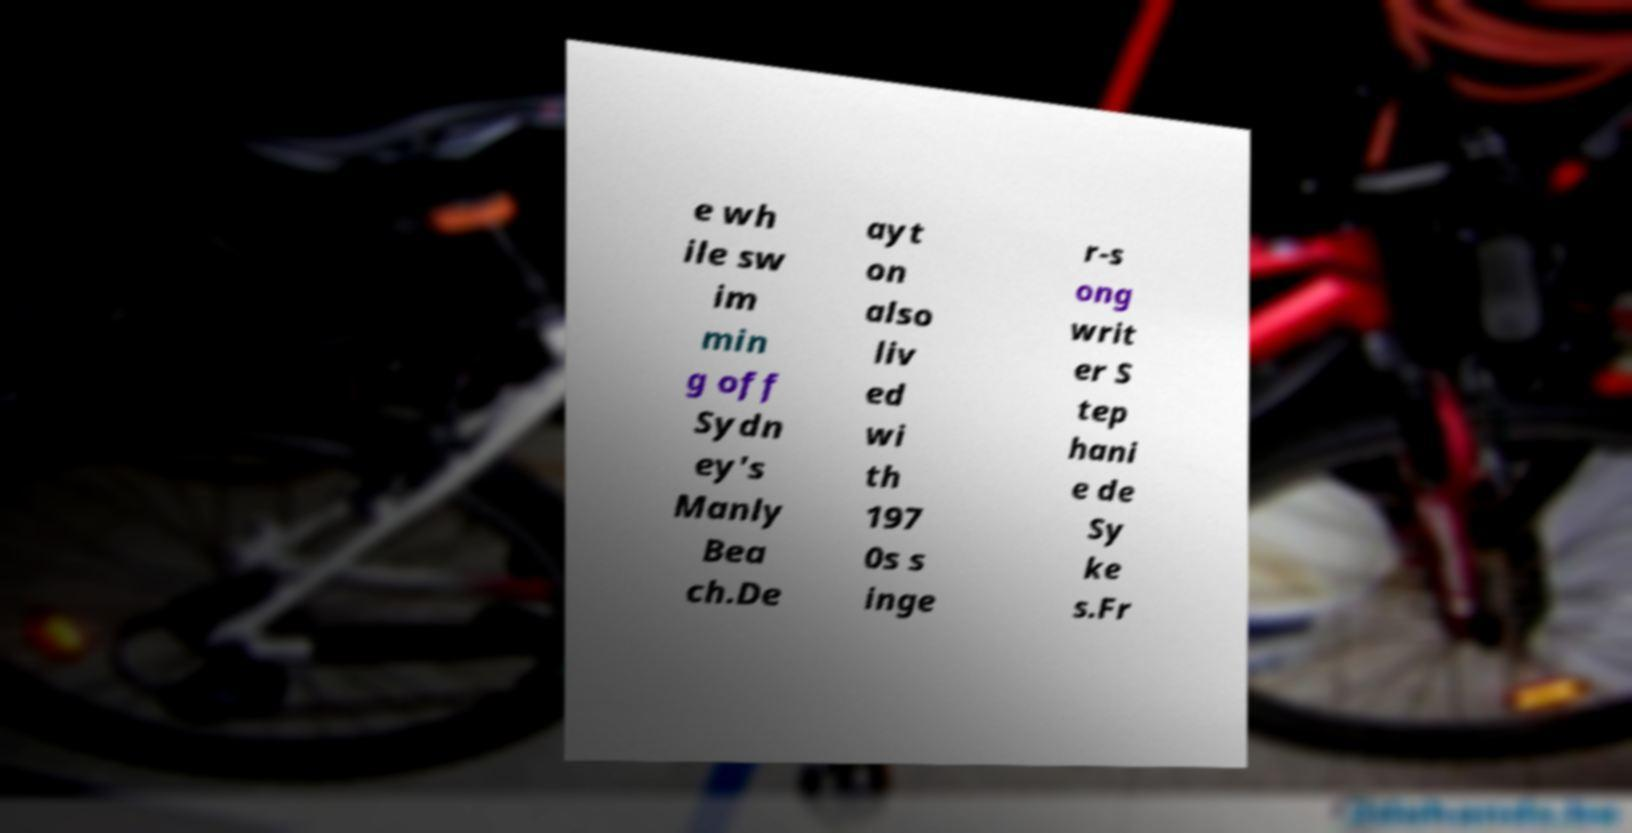For documentation purposes, I need the text within this image transcribed. Could you provide that? e wh ile sw im min g off Sydn ey's Manly Bea ch.De ayt on also liv ed wi th 197 0s s inge r-s ong writ er S tep hani e de Sy ke s.Fr 